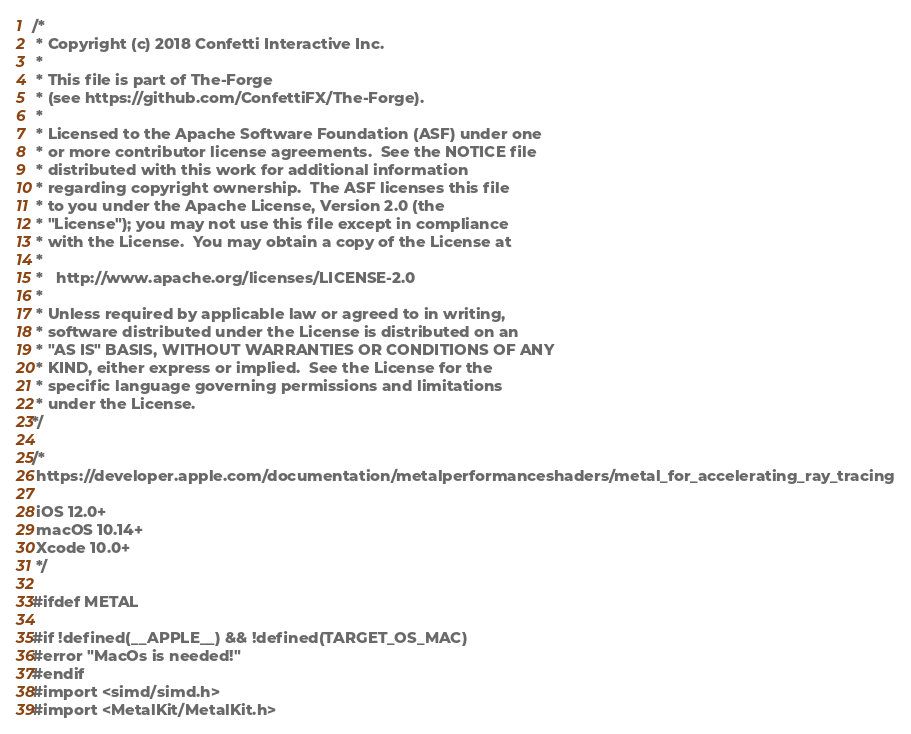<code> <loc_0><loc_0><loc_500><loc_500><_ObjectiveC_>/*
 * Copyright (c) 2018 Confetti Interactive Inc.
 *
 * This file is part of The-Forge
 * (see https://github.com/ConfettiFX/The-Forge).
 *
 * Licensed to the Apache Software Foundation (ASF) under one
 * or more contributor license agreements.  See the NOTICE file
 * distributed with this work for additional information
 * regarding copyright ownership.  The ASF licenses this file
 * to you under the Apache License, Version 2.0 (the
 * "License"); you may not use this file except in compliance
 * with the License.  You may obtain a copy of the License at
 *
 *   http://www.apache.org/licenses/LICENSE-2.0
 *
 * Unless required by applicable law or agreed to in writing,
 * software distributed under the License is distributed on an
 * "AS IS" BASIS, WITHOUT WARRANTIES OR CONDITIONS OF ANY
 * KIND, either express or implied.  See the License for the
 * specific language governing permissions and limitations
 * under the License.
*/

/*
 https://developer.apple.com/documentation/metalperformanceshaders/metal_for_accelerating_ray_tracing
 
 iOS 12.0+
 macOS 10.14+
 Xcode 10.0+
 */

#ifdef METAL

#if !defined(__APPLE__) && !defined(TARGET_OS_MAC)
#error "MacOs is needed!"
#endif
#import <simd/simd.h>
#import <MetalKit/MetalKit.h></code> 